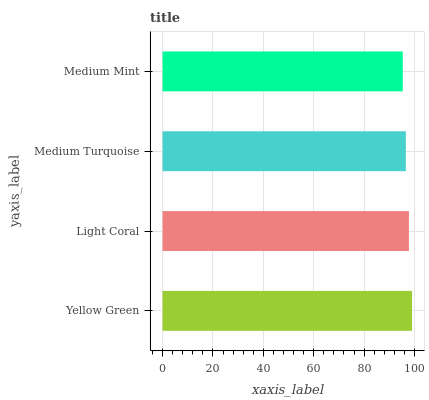Is Medium Mint the minimum?
Answer yes or no. Yes. Is Yellow Green the maximum?
Answer yes or no. Yes. Is Light Coral the minimum?
Answer yes or no. No. Is Light Coral the maximum?
Answer yes or no. No. Is Yellow Green greater than Light Coral?
Answer yes or no. Yes. Is Light Coral less than Yellow Green?
Answer yes or no. Yes. Is Light Coral greater than Yellow Green?
Answer yes or no. No. Is Yellow Green less than Light Coral?
Answer yes or no. No. Is Light Coral the high median?
Answer yes or no. Yes. Is Medium Turquoise the low median?
Answer yes or no. Yes. Is Medium Mint the high median?
Answer yes or no. No. Is Medium Mint the low median?
Answer yes or no. No. 